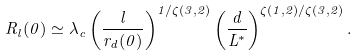Convert formula to latex. <formula><loc_0><loc_0><loc_500><loc_500>R _ { l } ( 0 ) \simeq \lambda _ { c } \left ( \frac { l } { r _ { d } ( 0 ) } \right ) ^ { 1 / \zeta ( 3 , 2 ) } \left ( \frac { d } { L ^ { * } } \right ) ^ { \zeta ( 1 , 2 ) / \zeta ( 3 , 2 ) } .</formula> 